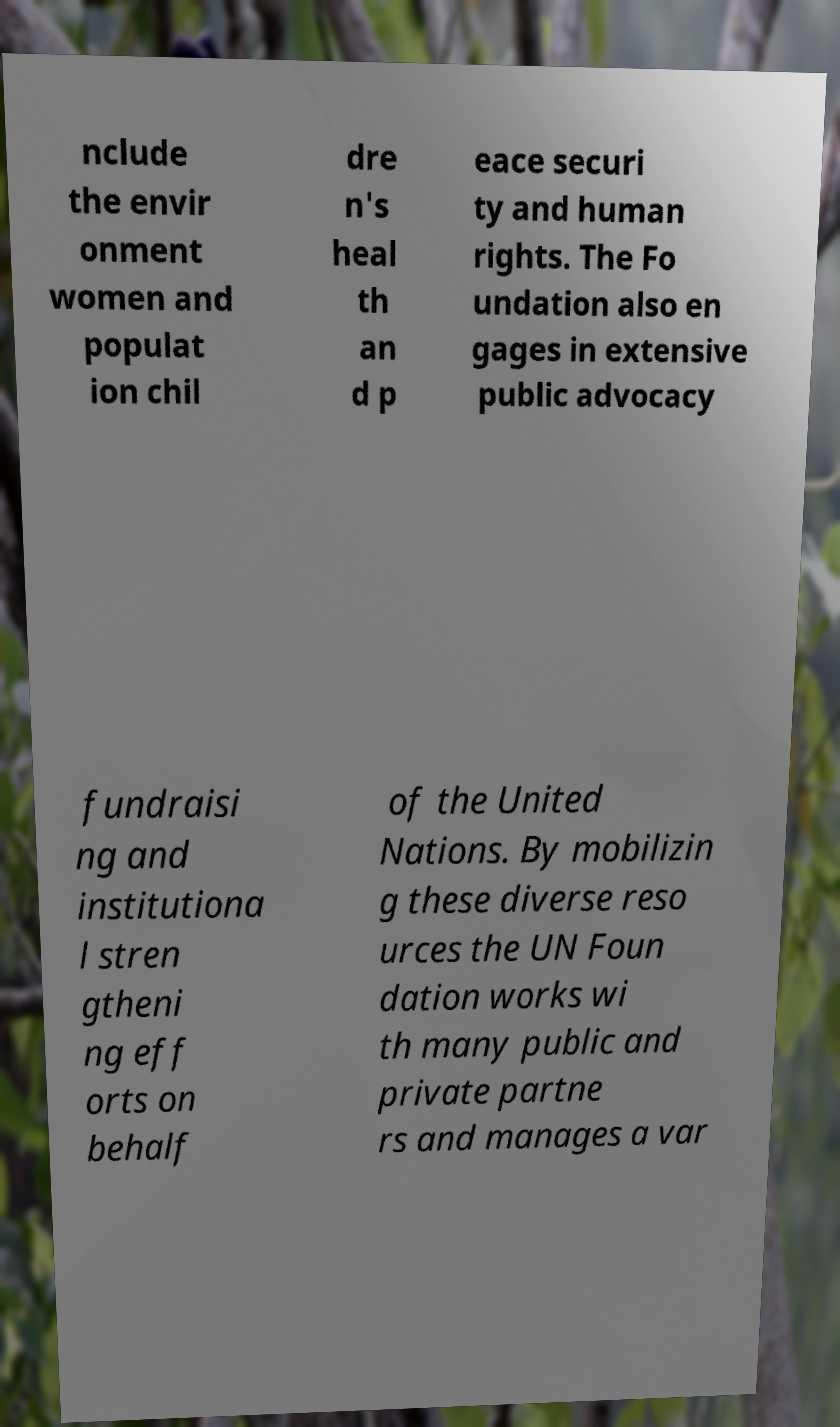I need the written content from this picture converted into text. Can you do that? nclude the envir onment women and populat ion chil dre n's heal th an d p eace securi ty and human rights. The Fo undation also en gages in extensive public advocacy fundraisi ng and institutiona l stren gtheni ng eff orts on behalf of the United Nations. By mobilizin g these diverse reso urces the UN Foun dation works wi th many public and private partne rs and manages a var 